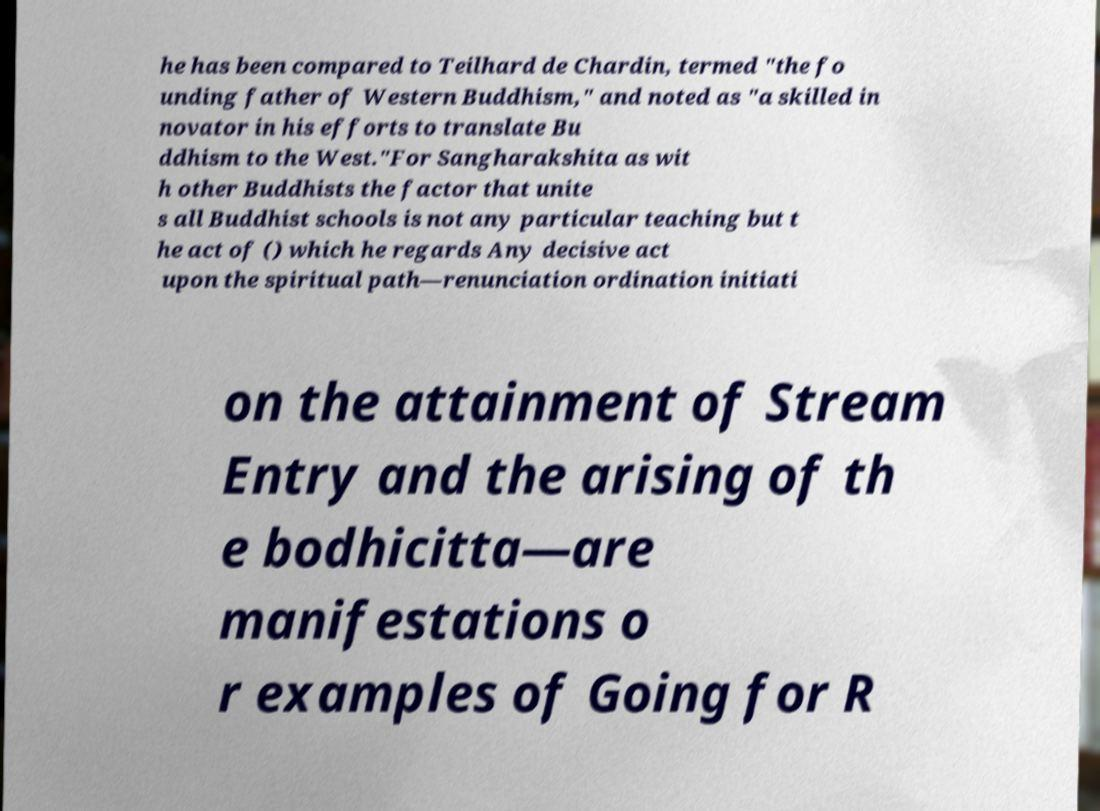Could you extract and type out the text from this image? he has been compared to Teilhard de Chardin, termed "the fo unding father of Western Buddhism," and noted as "a skilled in novator in his efforts to translate Bu ddhism to the West."For Sangharakshita as wit h other Buddhists the factor that unite s all Buddhist schools is not any particular teaching but t he act of () which he regards Any decisive act upon the spiritual path—renunciation ordination initiati on the attainment of Stream Entry and the arising of th e bodhicitta—are manifestations o r examples of Going for R 